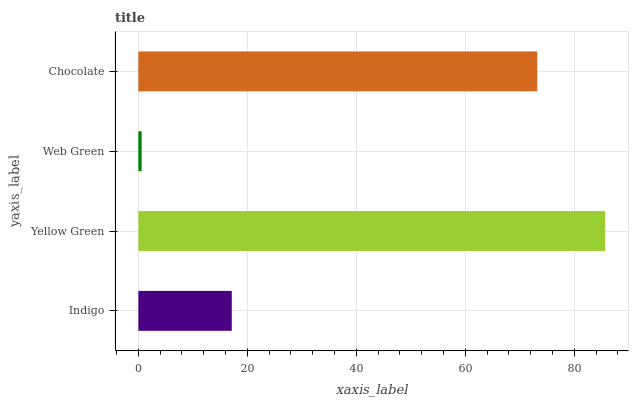Is Web Green the minimum?
Answer yes or no. Yes. Is Yellow Green the maximum?
Answer yes or no. Yes. Is Yellow Green the minimum?
Answer yes or no. No. Is Web Green the maximum?
Answer yes or no. No. Is Yellow Green greater than Web Green?
Answer yes or no. Yes. Is Web Green less than Yellow Green?
Answer yes or no. Yes. Is Web Green greater than Yellow Green?
Answer yes or no. No. Is Yellow Green less than Web Green?
Answer yes or no. No. Is Chocolate the high median?
Answer yes or no. Yes. Is Indigo the low median?
Answer yes or no. Yes. Is Yellow Green the high median?
Answer yes or no. No. Is Chocolate the low median?
Answer yes or no. No. 